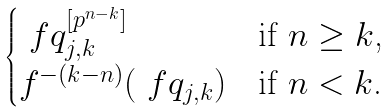<formula> <loc_0><loc_0><loc_500><loc_500>\begin{cases} \ f q _ { j , k } ^ { [ p ^ { n - k } ] } & \text {if $n \geq k$,} \\ f ^ { - ( k - n ) } ( \ f q _ { j , k } ) & \text {if $n < k$.} \end{cases}</formula> 